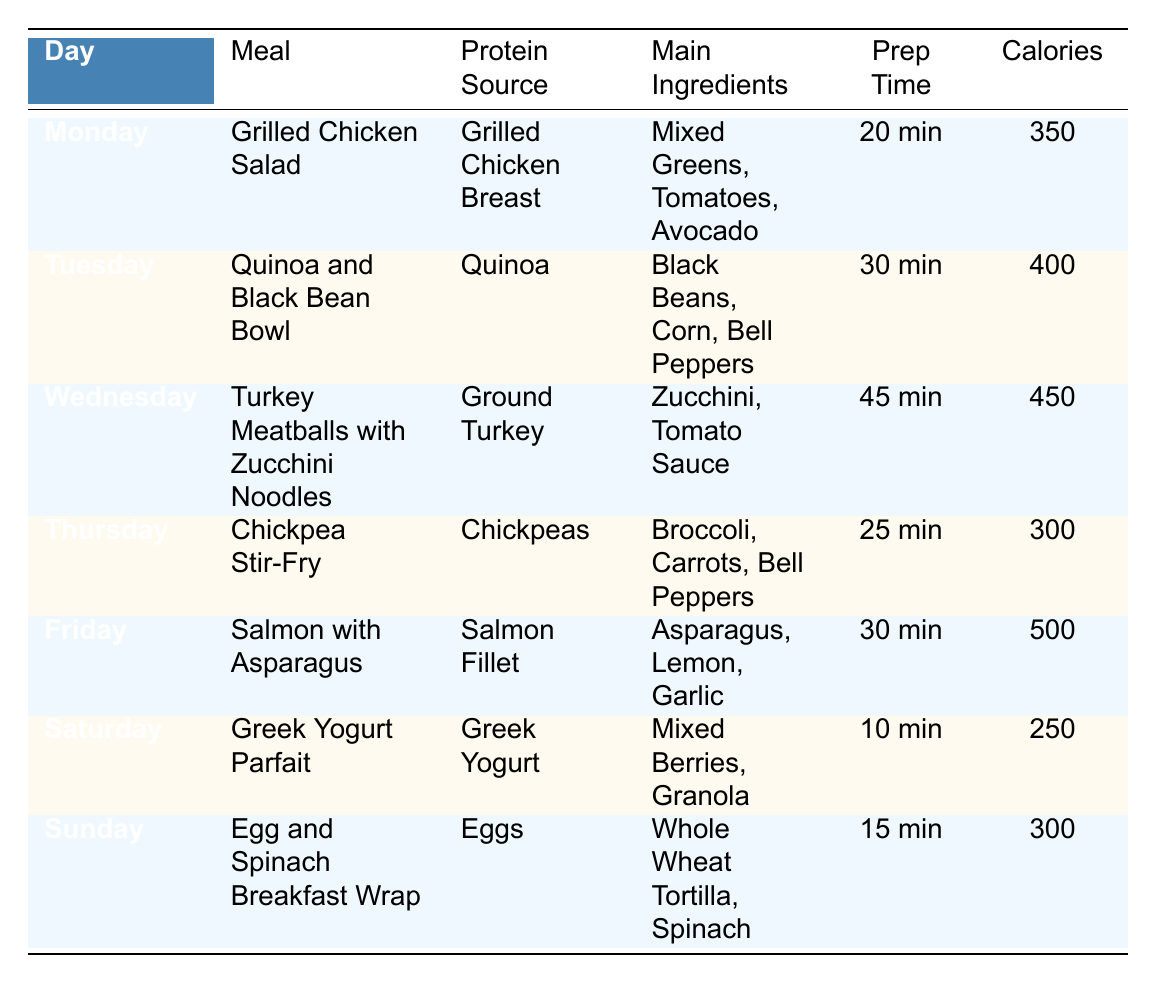What meal has the highest calorie count? The table shows the calories for each meal. By comparing the values, Friday's meal, "Salmon with Asparagus," has the highest calorie count at 500.
Answer: 500 Which protein source is used in the Tuesday meal? The Tuesday meal listed in the table is "Quinoa and Black Bean Bowl," and the protein source specified is Quinoa.
Answer: Quinoa How much prep time is required for the Turkey Meatballs meal? The Turkey Meatballs meal occurs on Wednesday, and the prep time listed in the table is 45 minutes.
Answer: 45 minutes True or False: The Chickpea Stir-Fry has a prep time longer than 30 minutes. The prep time for the Chickpea Stir-Fry is 25 minutes, which is less than 30 minutes, making the statement false.
Answer: False What is the average calorie count for the meals over the week? To find the average, first add all calorie counts: 350 + 400 + 450 + 300 + 500 + 250 + 300 = 2550. There are 7 meals, so the average is 2550 / 7 = 365.71.
Answer: 365.71 Which meal on Saturday has the least prep time? The meal identified for Saturday is "Greek Yogurt Parfait" with a prep time of 10 minutes, which is the smallest among all listed meals.
Answer: 10 minutes Which protein source appears most frequently in the meal prep plans? The protein sources are Grilled Chicken Breast, Quinoa, Ground Turkey, Chickpeas, Salmon Fillet, Greek Yogurt, and Eggs. To count them, each is unique; thus, they all appear one time, indicating no protein source appears more than once.
Answer: None What are the additional ingredients used in the Grilled Chicken Salad? The table provides the additional ingredients for this meal as Mixed Greens, Cherry Tomatoes, Cucumbers, Avocado, and Olive Oil.
Answer: Mixed Greens, Cherry Tomatoes, Cucumbers, Avocado, Olive Oil On which day is the meal with the second lowest calorie count served? From the table, the meal with the lowest calorie count is the Greek Yogurt Parfait (250 calories). The second lowest is the Chickpea Stir-Fry (300 calories) on Thursday.
Answer: Thursday If I want to prepare meals under 30 minutes, how many options do I have? The meals that can be prepared in under 30 minutes are Grilled Chicken Salad (20 minutes), Chickpea Stir-Fry (25 minutes), Salmon with Asparagus (30 minutes), and Greek Yogurt Parfait (10 minutes), thus totaling 4 options.
Answer: 4 